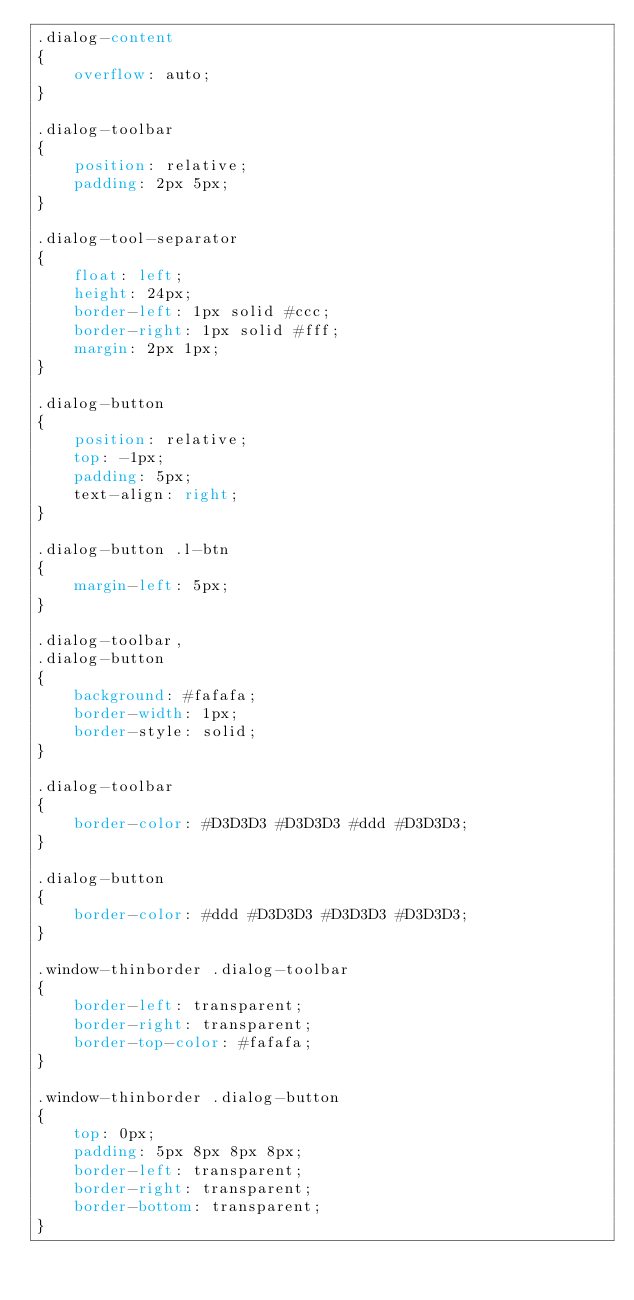Convert code to text. <code><loc_0><loc_0><loc_500><loc_500><_CSS_>.dialog-content
{
    overflow: auto;
}

.dialog-toolbar
{
    position: relative;
    padding: 2px 5px;
}

.dialog-tool-separator
{
    float: left;
    height: 24px;
    border-left: 1px solid #ccc;
    border-right: 1px solid #fff;
    margin: 2px 1px;
}

.dialog-button
{
    position: relative;
    top: -1px;
    padding: 5px;
    text-align: right;
}

.dialog-button .l-btn
{
    margin-left: 5px;
}

.dialog-toolbar,
.dialog-button
{
    background: #fafafa;
    border-width: 1px;
    border-style: solid;
}

.dialog-toolbar
{
    border-color: #D3D3D3 #D3D3D3 #ddd #D3D3D3;
}

.dialog-button
{
    border-color: #ddd #D3D3D3 #D3D3D3 #D3D3D3;
}

.window-thinborder .dialog-toolbar
{
    border-left: transparent;
    border-right: transparent;
    border-top-color: #fafafa;
}

.window-thinborder .dialog-button
{
    top: 0px;
    padding: 5px 8px 8px 8px;
    border-left: transparent;
    border-right: transparent;
    border-bottom: transparent;
}
</code> 